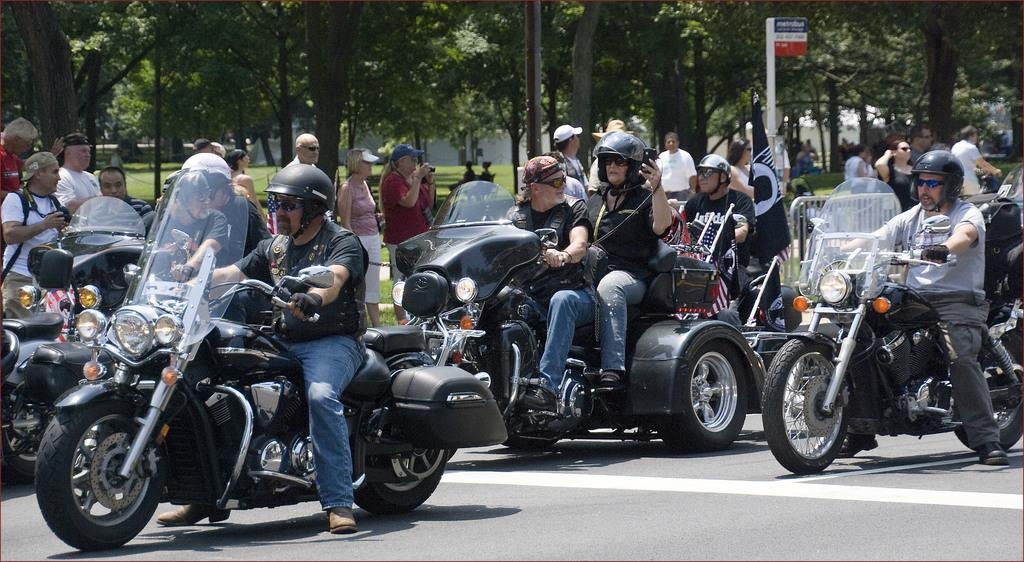Please provide a concise description of this image. In this picture there are group of people riding vehicle on a road. Towards the left there is a bike and one person on it. In the middle there are two persons on the bike. In the right there is one person on the bike. In the background there are group of trees and people. 